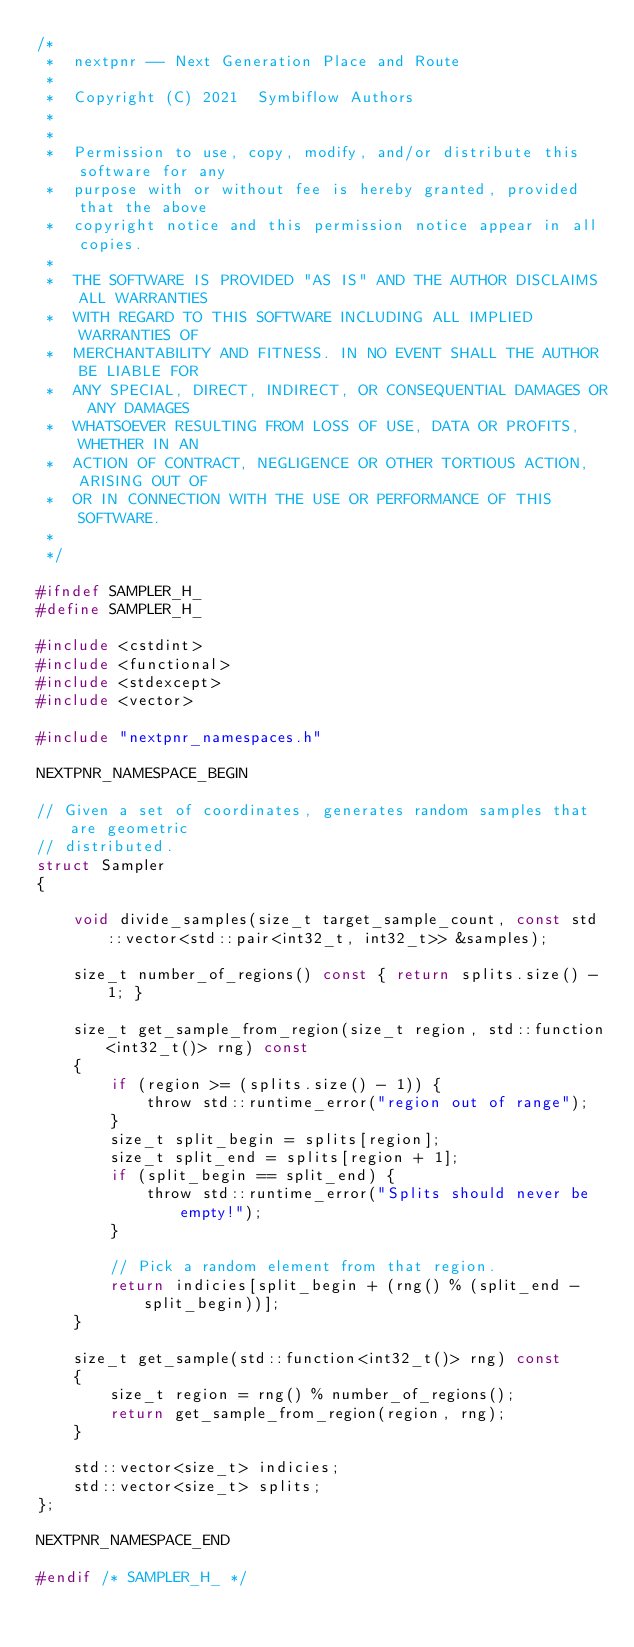<code> <loc_0><loc_0><loc_500><loc_500><_C_>/*
 *  nextpnr -- Next Generation Place and Route
 *
 *  Copyright (C) 2021  Symbiflow Authors
 *
 *
 *  Permission to use, copy, modify, and/or distribute this software for any
 *  purpose with or without fee is hereby granted, provided that the above
 *  copyright notice and this permission notice appear in all copies.
 *
 *  THE SOFTWARE IS PROVIDED "AS IS" AND THE AUTHOR DISCLAIMS ALL WARRANTIES
 *  WITH REGARD TO THIS SOFTWARE INCLUDING ALL IMPLIED WARRANTIES OF
 *  MERCHANTABILITY AND FITNESS. IN NO EVENT SHALL THE AUTHOR BE LIABLE FOR
 *  ANY SPECIAL, DIRECT, INDIRECT, OR CONSEQUENTIAL DAMAGES OR ANY DAMAGES
 *  WHATSOEVER RESULTING FROM LOSS OF USE, DATA OR PROFITS, WHETHER IN AN
 *  ACTION OF CONTRACT, NEGLIGENCE OR OTHER TORTIOUS ACTION, ARISING OUT OF
 *  OR IN CONNECTION WITH THE USE OR PERFORMANCE OF THIS SOFTWARE.
 *
 */

#ifndef SAMPLER_H_
#define SAMPLER_H_

#include <cstdint>
#include <functional>
#include <stdexcept>
#include <vector>

#include "nextpnr_namespaces.h"

NEXTPNR_NAMESPACE_BEGIN

// Given a set of coordinates, generates random samples that are geometric
// distributed.
struct Sampler
{

    void divide_samples(size_t target_sample_count, const std::vector<std::pair<int32_t, int32_t>> &samples);

    size_t number_of_regions() const { return splits.size() - 1; }

    size_t get_sample_from_region(size_t region, std::function<int32_t()> rng) const
    {
        if (region >= (splits.size() - 1)) {
            throw std::runtime_error("region out of range");
        }
        size_t split_begin = splits[region];
        size_t split_end = splits[region + 1];
        if (split_begin == split_end) {
            throw std::runtime_error("Splits should never be empty!");
        }

        // Pick a random element from that region.
        return indicies[split_begin + (rng() % (split_end - split_begin))];
    }

    size_t get_sample(std::function<int32_t()> rng) const
    {
        size_t region = rng() % number_of_regions();
        return get_sample_from_region(region, rng);
    }

    std::vector<size_t> indicies;
    std::vector<size_t> splits;
};

NEXTPNR_NAMESPACE_END

#endif /* SAMPLER_H_ */
</code> 